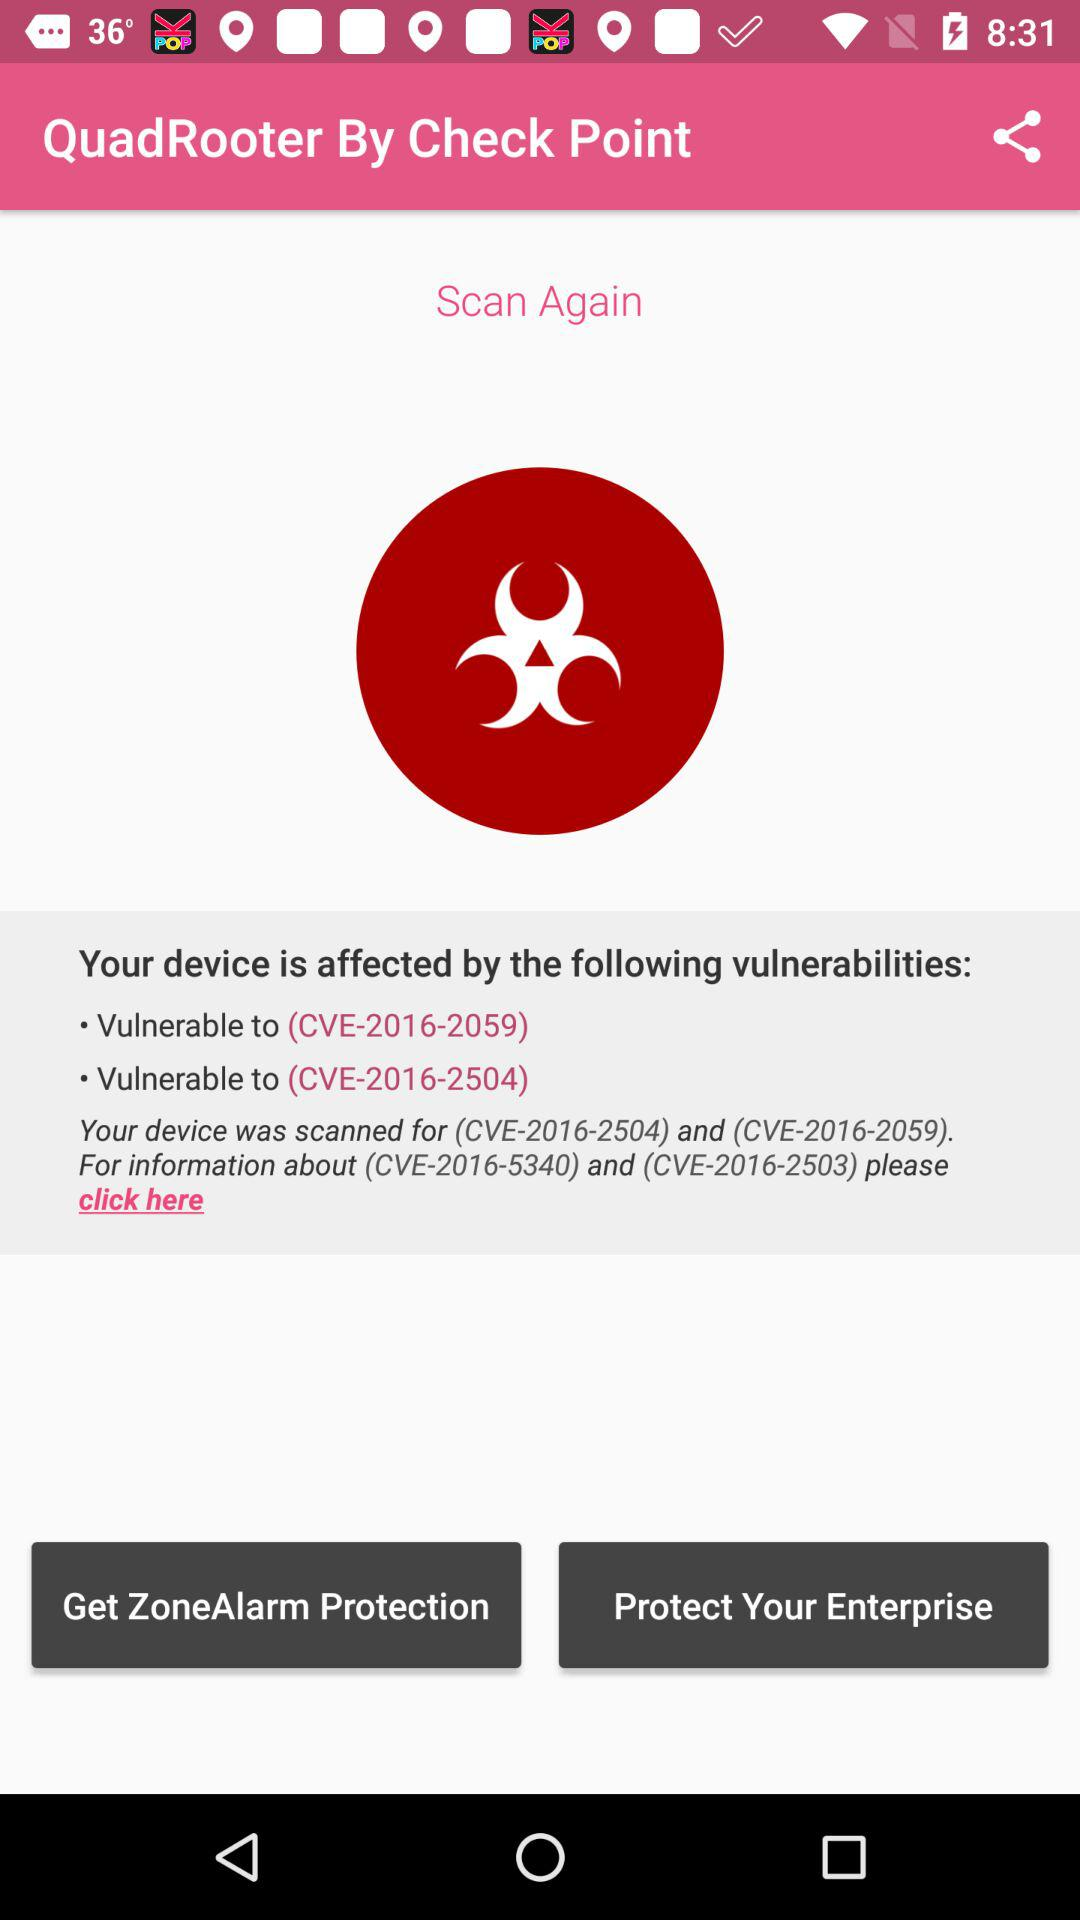How many vulnerabilities are the user affected by?
Answer the question using a single word or phrase. 2 